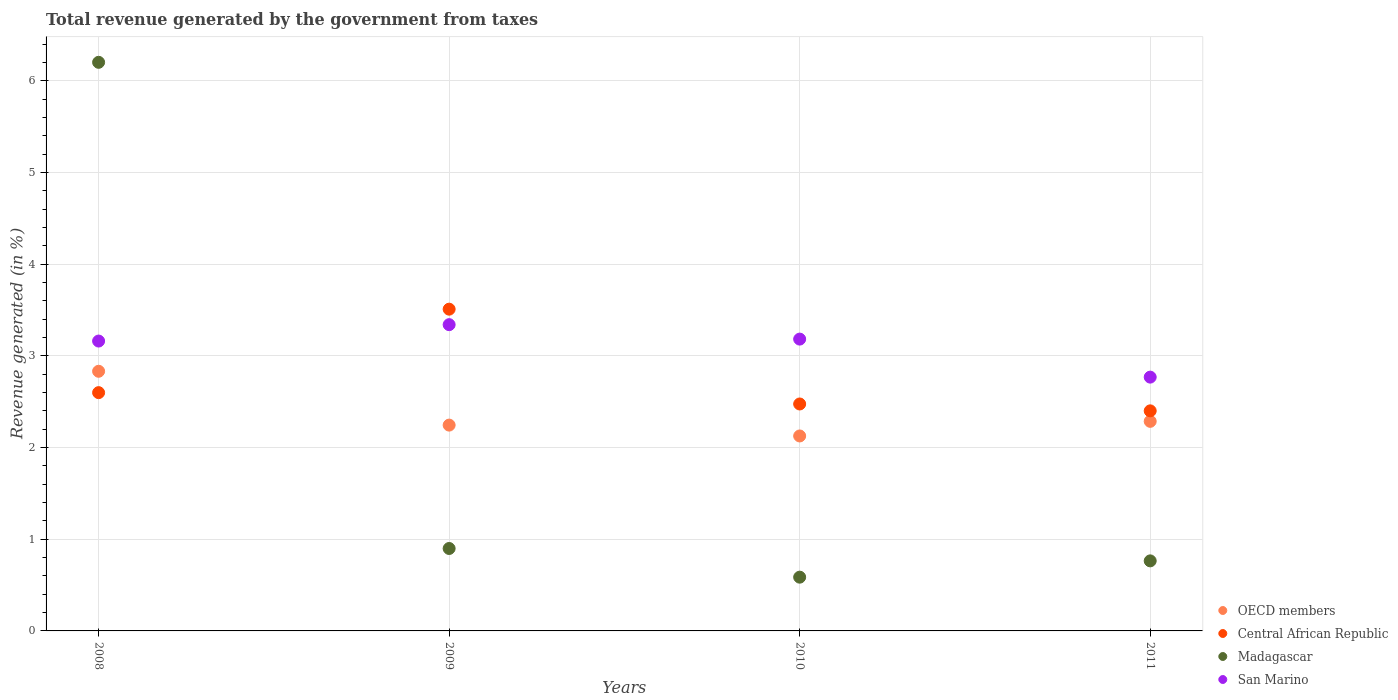How many different coloured dotlines are there?
Ensure brevity in your answer.  4. What is the total revenue generated in Central African Republic in 2010?
Offer a terse response. 2.47. Across all years, what is the maximum total revenue generated in Central African Republic?
Provide a succinct answer. 3.51. Across all years, what is the minimum total revenue generated in Central African Republic?
Your response must be concise. 2.4. In which year was the total revenue generated in OECD members maximum?
Give a very brief answer. 2008. In which year was the total revenue generated in OECD members minimum?
Offer a terse response. 2010. What is the total total revenue generated in OECD members in the graph?
Make the answer very short. 9.49. What is the difference between the total revenue generated in Central African Republic in 2008 and that in 2011?
Offer a terse response. 0.2. What is the difference between the total revenue generated in Central African Republic in 2011 and the total revenue generated in San Marino in 2010?
Make the answer very short. -0.78. What is the average total revenue generated in Madagascar per year?
Offer a terse response. 2.11. In the year 2009, what is the difference between the total revenue generated in OECD members and total revenue generated in San Marino?
Offer a very short reply. -1.1. What is the ratio of the total revenue generated in Central African Republic in 2010 to that in 2011?
Make the answer very short. 1.03. Is the total revenue generated in San Marino in 2009 less than that in 2010?
Offer a very short reply. No. Is the difference between the total revenue generated in OECD members in 2008 and 2010 greater than the difference between the total revenue generated in San Marino in 2008 and 2010?
Provide a succinct answer. Yes. What is the difference between the highest and the second highest total revenue generated in Madagascar?
Make the answer very short. 5.3. What is the difference between the highest and the lowest total revenue generated in Madagascar?
Your response must be concise. 5.61. Is it the case that in every year, the sum of the total revenue generated in Madagascar and total revenue generated in Central African Republic  is greater than the total revenue generated in OECD members?
Ensure brevity in your answer.  Yes. Does the total revenue generated in Central African Republic monotonically increase over the years?
Keep it short and to the point. No. Is the total revenue generated in San Marino strictly less than the total revenue generated in OECD members over the years?
Provide a succinct answer. No. How many dotlines are there?
Make the answer very short. 4. How many years are there in the graph?
Make the answer very short. 4. Are the values on the major ticks of Y-axis written in scientific E-notation?
Provide a short and direct response. No. How are the legend labels stacked?
Provide a succinct answer. Vertical. What is the title of the graph?
Offer a very short reply. Total revenue generated by the government from taxes. What is the label or title of the Y-axis?
Give a very brief answer. Revenue generated (in %). What is the Revenue generated (in %) in OECD members in 2008?
Your answer should be very brief. 2.83. What is the Revenue generated (in %) in Central African Republic in 2008?
Give a very brief answer. 2.6. What is the Revenue generated (in %) of Madagascar in 2008?
Provide a succinct answer. 6.2. What is the Revenue generated (in %) of San Marino in 2008?
Give a very brief answer. 3.16. What is the Revenue generated (in %) in OECD members in 2009?
Ensure brevity in your answer.  2.24. What is the Revenue generated (in %) in Central African Republic in 2009?
Offer a very short reply. 3.51. What is the Revenue generated (in %) of Madagascar in 2009?
Keep it short and to the point. 0.9. What is the Revenue generated (in %) in San Marino in 2009?
Provide a short and direct response. 3.34. What is the Revenue generated (in %) in OECD members in 2010?
Provide a short and direct response. 2.13. What is the Revenue generated (in %) of Central African Republic in 2010?
Your answer should be compact. 2.47. What is the Revenue generated (in %) in Madagascar in 2010?
Make the answer very short. 0.59. What is the Revenue generated (in %) in San Marino in 2010?
Your response must be concise. 3.18. What is the Revenue generated (in %) in OECD members in 2011?
Ensure brevity in your answer.  2.29. What is the Revenue generated (in %) in Central African Republic in 2011?
Your response must be concise. 2.4. What is the Revenue generated (in %) of Madagascar in 2011?
Ensure brevity in your answer.  0.76. What is the Revenue generated (in %) of San Marino in 2011?
Make the answer very short. 2.77. Across all years, what is the maximum Revenue generated (in %) in OECD members?
Keep it short and to the point. 2.83. Across all years, what is the maximum Revenue generated (in %) in Central African Republic?
Keep it short and to the point. 3.51. Across all years, what is the maximum Revenue generated (in %) of Madagascar?
Your response must be concise. 6.2. Across all years, what is the maximum Revenue generated (in %) of San Marino?
Provide a succinct answer. 3.34. Across all years, what is the minimum Revenue generated (in %) in OECD members?
Provide a succinct answer. 2.13. Across all years, what is the minimum Revenue generated (in %) in Central African Republic?
Offer a very short reply. 2.4. Across all years, what is the minimum Revenue generated (in %) of Madagascar?
Make the answer very short. 0.59. Across all years, what is the minimum Revenue generated (in %) of San Marino?
Give a very brief answer. 2.77. What is the total Revenue generated (in %) of OECD members in the graph?
Your answer should be compact. 9.49. What is the total Revenue generated (in %) of Central African Republic in the graph?
Provide a succinct answer. 10.98. What is the total Revenue generated (in %) of Madagascar in the graph?
Your answer should be very brief. 8.45. What is the total Revenue generated (in %) in San Marino in the graph?
Provide a short and direct response. 12.45. What is the difference between the Revenue generated (in %) of OECD members in 2008 and that in 2009?
Keep it short and to the point. 0.59. What is the difference between the Revenue generated (in %) in Central African Republic in 2008 and that in 2009?
Provide a succinct answer. -0.91. What is the difference between the Revenue generated (in %) in Madagascar in 2008 and that in 2009?
Your answer should be compact. 5.3. What is the difference between the Revenue generated (in %) of San Marino in 2008 and that in 2009?
Make the answer very short. -0.18. What is the difference between the Revenue generated (in %) of OECD members in 2008 and that in 2010?
Offer a terse response. 0.71. What is the difference between the Revenue generated (in %) of Central African Republic in 2008 and that in 2010?
Provide a short and direct response. 0.12. What is the difference between the Revenue generated (in %) of Madagascar in 2008 and that in 2010?
Give a very brief answer. 5.61. What is the difference between the Revenue generated (in %) of San Marino in 2008 and that in 2010?
Provide a short and direct response. -0.02. What is the difference between the Revenue generated (in %) in OECD members in 2008 and that in 2011?
Make the answer very short. 0.55. What is the difference between the Revenue generated (in %) in Central African Republic in 2008 and that in 2011?
Your response must be concise. 0.2. What is the difference between the Revenue generated (in %) of Madagascar in 2008 and that in 2011?
Offer a very short reply. 5.44. What is the difference between the Revenue generated (in %) of San Marino in 2008 and that in 2011?
Offer a very short reply. 0.39. What is the difference between the Revenue generated (in %) of OECD members in 2009 and that in 2010?
Offer a very short reply. 0.12. What is the difference between the Revenue generated (in %) in Central African Republic in 2009 and that in 2010?
Give a very brief answer. 1.03. What is the difference between the Revenue generated (in %) of Madagascar in 2009 and that in 2010?
Make the answer very short. 0.31. What is the difference between the Revenue generated (in %) of San Marino in 2009 and that in 2010?
Your answer should be compact. 0.16. What is the difference between the Revenue generated (in %) in OECD members in 2009 and that in 2011?
Offer a very short reply. -0.04. What is the difference between the Revenue generated (in %) of Central African Republic in 2009 and that in 2011?
Offer a very short reply. 1.11. What is the difference between the Revenue generated (in %) in Madagascar in 2009 and that in 2011?
Keep it short and to the point. 0.14. What is the difference between the Revenue generated (in %) of San Marino in 2009 and that in 2011?
Your answer should be compact. 0.57. What is the difference between the Revenue generated (in %) of OECD members in 2010 and that in 2011?
Your response must be concise. -0.16. What is the difference between the Revenue generated (in %) in Central African Republic in 2010 and that in 2011?
Your answer should be compact. 0.07. What is the difference between the Revenue generated (in %) in Madagascar in 2010 and that in 2011?
Provide a succinct answer. -0.18. What is the difference between the Revenue generated (in %) in San Marino in 2010 and that in 2011?
Ensure brevity in your answer.  0.41. What is the difference between the Revenue generated (in %) of OECD members in 2008 and the Revenue generated (in %) of Central African Republic in 2009?
Your response must be concise. -0.68. What is the difference between the Revenue generated (in %) of OECD members in 2008 and the Revenue generated (in %) of Madagascar in 2009?
Your response must be concise. 1.93. What is the difference between the Revenue generated (in %) of OECD members in 2008 and the Revenue generated (in %) of San Marino in 2009?
Provide a succinct answer. -0.51. What is the difference between the Revenue generated (in %) in Central African Republic in 2008 and the Revenue generated (in %) in Madagascar in 2009?
Give a very brief answer. 1.7. What is the difference between the Revenue generated (in %) in Central African Republic in 2008 and the Revenue generated (in %) in San Marino in 2009?
Keep it short and to the point. -0.74. What is the difference between the Revenue generated (in %) of Madagascar in 2008 and the Revenue generated (in %) of San Marino in 2009?
Give a very brief answer. 2.86. What is the difference between the Revenue generated (in %) of OECD members in 2008 and the Revenue generated (in %) of Central African Republic in 2010?
Keep it short and to the point. 0.36. What is the difference between the Revenue generated (in %) in OECD members in 2008 and the Revenue generated (in %) in Madagascar in 2010?
Keep it short and to the point. 2.25. What is the difference between the Revenue generated (in %) in OECD members in 2008 and the Revenue generated (in %) in San Marino in 2010?
Your answer should be very brief. -0.35. What is the difference between the Revenue generated (in %) of Central African Republic in 2008 and the Revenue generated (in %) of Madagascar in 2010?
Keep it short and to the point. 2.01. What is the difference between the Revenue generated (in %) of Central African Republic in 2008 and the Revenue generated (in %) of San Marino in 2010?
Your answer should be very brief. -0.58. What is the difference between the Revenue generated (in %) in Madagascar in 2008 and the Revenue generated (in %) in San Marino in 2010?
Give a very brief answer. 3.02. What is the difference between the Revenue generated (in %) in OECD members in 2008 and the Revenue generated (in %) in Central African Republic in 2011?
Ensure brevity in your answer.  0.43. What is the difference between the Revenue generated (in %) in OECD members in 2008 and the Revenue generated (in %) in Madagascar in 2011?
Make the answer very short. 2.07. What is the difference between the Revenue generated (in %) of OECD members in 2008 and the Revenue generated (in %) of San Marino in 2011?
Make the answer very short. 0.06. What is the difference between the Revenue generated (in %) of Central African Republic in 2008 and the Revenue generated (in %) of Madagascar in 2011?
Give a very brief answer. 1.83. What is the difference between the Revenue generated (in %) of Central African Republic in 2008 and the Revenue generated (in %) of San Marino in 2011?
Keep it short and to the point. -0.17. What is the difference between the Revenue generated (in %) in Madagascar in 2008 and the Revenue generated (in %) in San Marino in 2011?
Ensure brevity in your answer.  3.43. What is the difference between the Revenue generated (in %) in OECD members in 2009 and the Revenue generated (in %) in Central African Republic in 2010?
Provide a succinct answer. -0.23. What is the difference between the Revenue generated (in %) of OECD members in 2009 and the Revenue generated (in %) of Madagascar in 2010?
Your response must be concise. 1.66. What is the difference between the Revenue generated (in %) in OECD members in 2009 and the Revenue generated (in %) in San Marino in 2010?
Your answer should be compact. -0.94. What is the difference between the Revenue generated (in %) of Central African Republic in 2009 and the Revenue generated (in %) of Madagascar in 2010?
Offer a terse response. 2.92. What is the difference between the Revenue generated (in %) of Central African Republic in 2009 and the Revenue generated (in %) of San Marino in 2010?
Your answer should be very brief. 0.33. What is the difference between the Revenue generated (in %) of Madagascar in 2009 and the Revenue generated (in %) of San Marino in 2010?
Offer a very short reply. -2.28. What is the difference between the Revenue generated (in %) of OECD members in 2009 and the Revenue generated (in %) of Central African Republic in 2011?
Give a very brief answer. -0.16. What is the difference between the Revenue generated (in %) of OECD members in 2009 and the Revenue generated (in %) of Madagascar in 2011?
Your response must be concise. 1.48. What is the difference between the Revenue generated (in %) in OECD members in 2009 and the Revenue generated (in %) in San Marino in 2011?
Offer a terse response. -0.52. What is the difference between the Revenue generated (in %) of Central African Republic in 2009 and the Revenue generated (in %) of Madagascar in 2011?
Your response must be concise. 2.74. What is the difference between the Revenue generated (in %) of Central African Republic in 2009 and the Revenue generated (in %) of San Marino in 2011?
Give a very brief answer. 0.74. What is the difference between the Revenue generated (in %) of Madagascar in 2009 and the Revenue generated (in %) of San Marino in 2011?
Your response must be concise. -1.87. What is the difference between the Revenue generated (in %) in OECD members in 2010 and the Revenue generated (in %) in Central African Republic in 2011?
Give a very brief answer. -0.27. What is the difference between the Revenue generated (in %) of OECD members in 2010 and the Revenue generated (in %) of Madagascar in 2011?
Your response must be concise. 1.36. What is the difference between the Revenue generated (in %) of OECD members in 2010 and the Revenue generated (in %) of San Marino in 2011?
Provide a succinct answer. -0.64. What is the difference between the Revenue generated (in %) in Central African Republic in 2010 and the Revenue generated (in %) in Madagascar in 2011?
Your answer should be compact. 1.71. What is the difference between the Revenue generated (in %) in Central African Republic in 2010 and the Revenue generated (in %) in San Marino in 2011?
Make the answer very short. -0.29. What is the difference between the Revenue generated (in %) of Madagascar in 2010 and the Revenue generated (in %) of San Marino in 2011?
Offer a very short reply. -2.18. What is the average Revenue generated (in %) in OECD members per year?
Make the answer very short. 2.37. What is the average Revenue generated (in %) in Central African Republic per year?
Offer a very short reply. 2.75. What is the average Revenue generated (in %) in Madagascar per year?
Keep it short and to the point. 2.11. What is the average Revenue generated (in %) of San Marino per year?
Your answer should be very brief. 3.11. In the year 2008, what is the difference between the Revenue generated (in %) of OECD members and Revenue generated (in %) of Central African Republic?
Ensure brevity in your answer.  0.23. In the year 2008, what is the difference between the Revenue generated (in %) of OECD members and Revenue generated (in %) of Madagascar?
Provide a short and direct response. -3.37. In the year 2008, what is the difference between the Revenue generated (in %) in OECD members and Revenue generated (in %) in San Marino?
Provide a succinct answer. -0.33. In the year 2008, what is the difference between the Revenue generated (in %) in Central African Republic and Revenue generated (in %) in Madagascar?
Offer a terse response. -3.6. In the year 2008, what is the difference between the Revenue generated (in %) of Central African Republic and Revenue generated (in %) of San Marino?
Provide a succinct answer. -0.56. In the year 2008, what is the difference between the Revenue generated (in %) in Madagascar and Revenue generated (in %) in San Marino?
Your answer should be compact. 3.04. In the year 2009, what is the difference between the Revenue generated (in %) in OECD members and Revenue generated (in %) in Central African Republic?
Offer a terse response. -1.26. In the year 2009, what is the difference between the Revenue generated (in %) in OECD members and Revenue generated (in %) in Madagascar?
Provide a short and direct response. 1.35. In the year 2009, what is the difference between the Revenue generated (in %) of OECD members and Revenue generated (in %) of San Marino?
Your answer should be very brief. -1.1. In the year 2009, what is the difference between the Revenue generated (in %) of Central African Republic and Revenue generated (in %) of Madagascar?
Make the answer very short. 2.61. In the year 2009, what is the difference between the Revenue generated (in %) of Central African Republic and Revenue generated (in %) of San Marino?
Offer a terse response. 0.17. In the year 2009, what is the difference between the Revenue generated (in %) in Madagascar and Revenue generated (in %) in San Marino?
Your answer should be compact. -2.44. In the year 2010, what is the difference between the Revenue generated (in %) of OECD members and Revenue generated (in %) of Central African Republic?
Offer a terse response. -0.35. In the year 2010, what is the difference between the Revenue generated (in %) in OECD members and Revenue generated (in %) in Madagascar?
Provide a short and direct response. 1.54. In the year 2010, what is the difference between the Revenue generated (in %) of OECD members and Revenue generated (in %) of San Marino?
Offer a very short reply. -1.06. In the year 2010, what is the difference between the Revenue generated (in %) of Central African Republic and Revenue generated (in %) of Madagascar?
Your response must be concise. 1.89. In the year 2010, what is the difference between the Revenue generated (in %) of Central African Republic and Revenue generated (in %) of San Marino?
Ensure brevity in your answer.  -0.71. In the year 2010, what is the difference between the Revenue generated (in %) of Madagascar and Revenue generated (in %) of San Marino?
Provide a short and direct response. -2.6. In the year 2011, what is the difference between the Revenue generated (in %) in OECD members and Revenue generated (in %) in Central African Republic?
Offer a very short reply. -0.11. In the year 2011, what is the difference between the Revenue generated (in %) in OECD members and Revenue generated (in %) in Madagascar?
Ensure brevity in your answer.  1.52. In the year 2011, what is the difference between the Revenue generated (in %) in OECD members and Revenue generated (in %) in San Marino?
Ensure brevity in your answer.  -0.48. In the year 2011, what is the difference between the Revenue generated (in %) in Central African Republic and Revenue generated (in %) in Madagascar?
Your answer should be compact. 1.64. In the year 2011, what is the difference between the Revenue generated (in %) in Central African Republic and Revenue generated (in %) in San Marino?
Make the answer very short. -0.37. In the year 2011, what is the difference between the Revenue generated (in %) of Madagascar and Revenue generated (in %) of San Marino?
Your answer should be very brief. -2. What is the ratio of the Revenue generated (in %) of OECD members in 2008 to that in 2009?
Make the answer very short. 1.26. What is the ratio of the Revenue generated (in %) of Central African Republic in 2008 to that in 2009?
Keep it short and to the point. 0.74. What is the ratio of the Revenue generated (in %) in Madagascar in 2008 to that in 2009?
Your answer should be very brief. 6.9. What is the ratio of the Revenue generated (in %) of San Marino in 2008 to that in 2009?
Your answer should be compact. 0.95. What is the ratio of the Revenue generated (in %) of OECD members in 2008 to that in 2010?
Make the answer very short. 1.33. What is the ratio of the Revenue generated (in %) in Madagascar in 2008 to that in 2010?
Your response must be concise. 10.58. What is the ratio of the Revenue generated (in %) of San Marino in 2008 to that in 2010?
Your answer should be very brief. 0.99. What is the ratio of the Revenue generated (in %) in OECD members in 2008 to that in 2011?
Ensure brevity in your answer.  1.24. What is the ratio of the Revenue generated (in %) in Central African Republic in 2008 to that in 2011?
Ensure brevity in your answer.  1.08. What is the ratio of the Revenue generated (in %) of Madagascar in 2008 to that in 2011?
Offer a very short reply. 8.12. What is the ratio of the Revenue generated (in %) of San Marino in 2008 to that in 2011?
Your response must be concise. 1.14. What is the ratio of the Revenue generated (in %) in OECD members in 2009 to that in 2010?
Provide a succinct answer. 1.06. What is the ratio of the Revenue generated (in %) of Central African Republic in 2009 to that in 2010?
Provide a short and direct response. 1.42. What is the ratio of the Revenue generated (in %) of Madagascar in 2009 to that in 2010?
Make the answer very short. 1.53. What is the ratio of the Revenue generated (in %) in San Marino in 2009 to that in 2010?
Offer a very short reply. 1.05. What is the ratio of the Revenue generated (in %) of Central African Republic in 2009 to that in 2011?
Your answer should be compact. 1.46. What is the ratio of the Revenue generated (in %) of Madagascar in 2009 to that in 2011?
Offer a terse response. 1.18. What is the ratio of the Revenue generated (in %) of San Marino in 2009 to that in 2011?
Keep it short and to the point. 1.21. What is the ratio of the Revenue generated (in %) of OECD members in 2010 to that in 2011?
Give a very brief answer. 0.93. What is the ratio of the Revenue generated (in %) in Central African Republic in 2010 to that in 2011?
Keep it short and to the point. 1.03. What is the ratio of the Revenue generated (in %) of Madagascar in 2010 to that in 2011?
Ensure brevity in your answer.  0.77. What is the ratio of the Revenue generated (in %) in San Marino in 2010 to that in 2011?
Give a very brief answer. 1.15. What is the difference between the highest and the second highest Revenue generated (in %) of OECD members?
Keep it short and to the point. 0.55. What is the difference between the highest and the second highest Revenue generated (in %) in Central African Republic?
Your response must be concise. 0.91. What is the difference between the highest and the second highest Revenue generated (in %) of Madagascar?
Offer a very short reply. 5.3. What is the difference between the highest and the second highest Revenue generated (in %) of San Marino?
Your answer should be compact. 0.16. What is the difference between the highest and the lowest Revenue generated (in %) in OECD members?
Ensure brevity in your answer.  0.71. What is the difference between the highest and the lowest Revenue generated (in %) of Central African Republic?
Your response must be concise. 1.11. What is the difference between the highest and the lowest Revenue generated (in %) of Madagascar?
Keep it short and to the point. 5.61. What is the difference between the highest and the lowest Revenue generated (in %) in San Marino?
Your response must be concise. 0.57. 